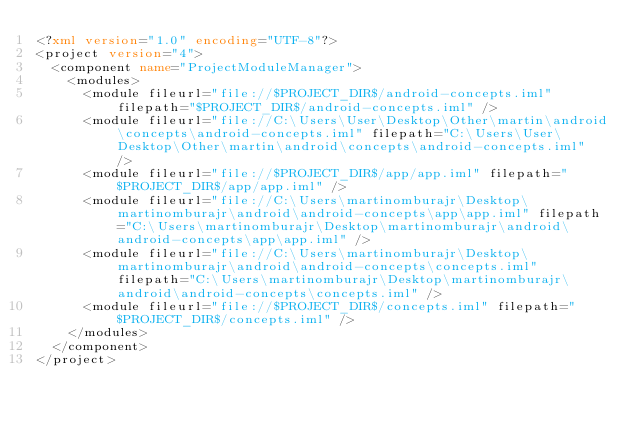<code> <loc_0><loc_0><loc_500><loc_500><_XML_><?xml version="1.0" encoding="UTF-8"?>
<project version="4">
  <component name="ProjectModuleManager">
    <modules>
      <module fileurl="file://$PROJECT_DIR$/android-concepts.iml" filepath="$PROJECT_DIR$/android-concepts.iml" />
      <module fileurl="file://C:\Users\User\Desktop\Other\martin\android\concepts\android-concepts.iml" filepath="C:\Users\User\Desktop\Other\martin\android\concepts\android-concepts.iml" />
      <module fileurl="file://$PROJECT_DIR$/app/app.iml" filepath="$PROJECT_DIR$/app/app.iml" />
      <module fileurl="file://C:\Users\martinomburajr\Desktop\martinomburajr\android\android-concepts\app\app.iml" filepath="C:\Users\martinomburajr\Desktop\martinomburajr\android\android-concepts\app\app.iml" />
      <module fileurl="file://C:\Users\martinomburajr\Desktop\martinomburajr\android\android-concepts\concepts.iml" filepath="C:\Users\martinomburajr\Desktop\martinomburajr\android\android-concepts\concepts.iml" />
      <module fileurl="file://$PROJECT_DIR$/concepts.iml" filepath="$PROJECT_DIR$/concepts.iml" />
    </modules>
  </component>
</project></code> 